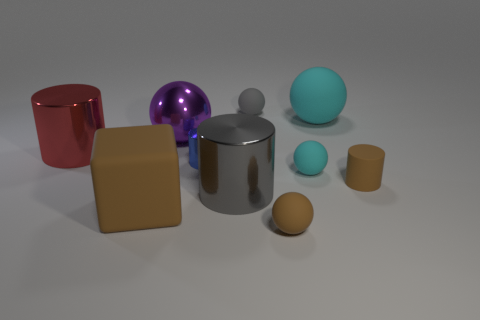Subtract all blue metal cylinders. How many cylinders are left? 3 Subtract all red cylinders. How many cylinders are left? 3 Subtract all cubes. How many objects are left? 9 Subtract 3 cylinders. How many cylinders are left? 1 Subtract all cyan spheres. How many brown cylinders are left? 1 Subtract all large green things. Subtract all large red metallic cylinders. How many objects are left? 9 Add 6 gray shiny cylinders. How many gray shiny cylinders are left? 7 Add 8 small green rubber cylinders. How many small green rubber cylinders exist? 8 Subtract 1 purple spheres. How many objects are left? 9 Subtract all blue blocks. Subtract all red cylinders. How many blocks are left? 1 